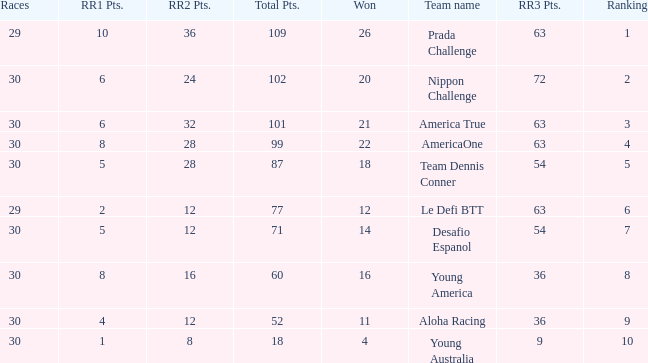If the total rr2 points for a win are 11, what is the number of points? 1.0. 